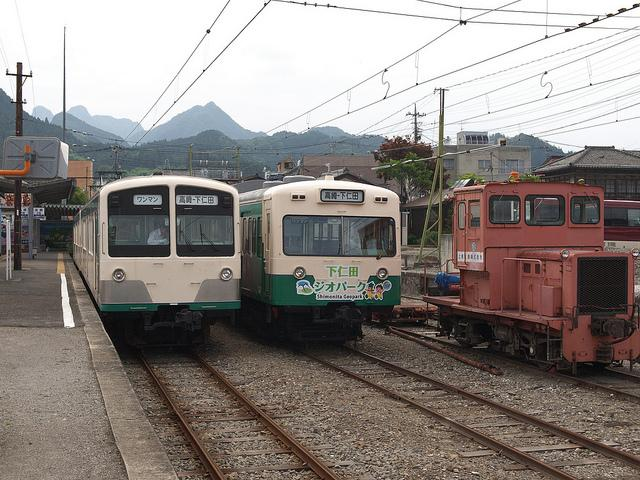What language is mainly spoken here? japanese 